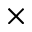Convert formula to latex. <formula><loc_0><loc_0><loc_500><loc_500>\times</formula> 